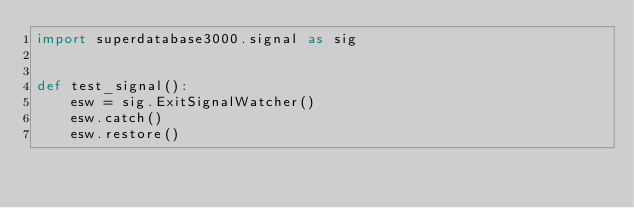<code> <loc_0><loc_0><loc_500><loc_500><_Python_>import superdatabase3000.signal as sig


def test_signal():
    esw = sig.ExitSignalWatcher()
    esw.catch()
    esw.restore()
</code> 